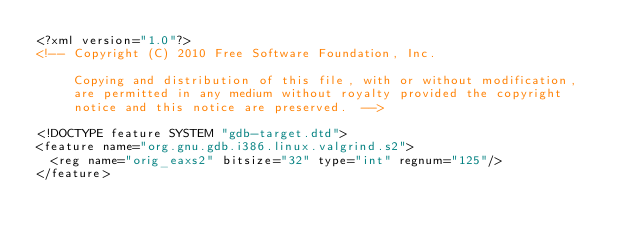Convert code to text. <code><loc_0><loc_0><loc_500><loc_500><_XML_><?xml version="1.0"?>
<!-- Copyright (C) 2010 Free Software Foundation, Inc.

     Copying and distribution of this file, with or without modification,
     are permitted in any medium without royalty provided the copyright
     notice and this notice are preserved.  -->

<!DOCTYPE feature SYSTEM "gdb-target.dtd">
<feature name="org.gnu.gdb.i386.linux.valgrind.s2">
  <reg name="orig_eaxs2" bitsize="32" type="int" regnum="125"/>
</feature>
</code> 